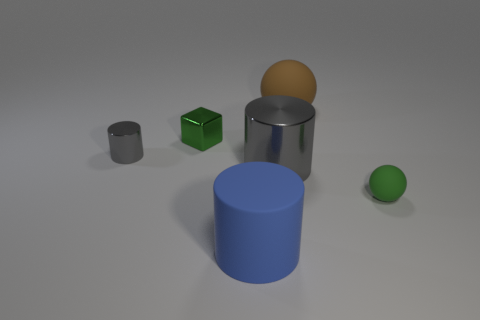What shape is the object that is the same color as the shiny cube?
Your answer should be very brief. Sphere. Does the rubber cylinder have the same color as the small rubber ball?
Give a very brief answer. No. Is there anything else of the same color as the rubber cylinder?
Your answer should be compact. No. What is the shape of the tiny thing that is the same material as the small gray cylinder?
Provide a succinct answer. Cube. How big is the metal thing to the right of the big blue thing?
Provide a succinct answer. Large. The large brown object has what shape?
Give a very brief answer. Sphere. Do the metal cube that is on the left side of the blue cylinder and the gray thing to the right of the tiny metal block have the same size?
Give a very brief answer. No. There is a sphere that is on the right side of the large thing behind the tiny green thing behind the large gray object; how big is it?
Provide a short and direct response. Small. The small green thing that is on the left side of the cylinder in front of the green object that is right of the small green metal thing is what shape?
Keep it short and to the point. Cube. What is the shape of the large matte object in front of the green matte sphere?
Your answer should be compact. Cylinder. 